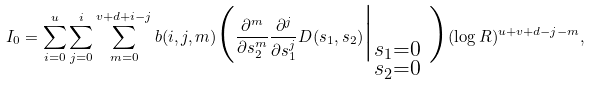Convert formula to latex. <formula><loc_0><loc_0><loc_500><loc_500>I _ { 0 } = \sum ^ { u } _ { i = 0 } \sum _ { j = 0 } ^ { i } \sum _ { m = 0 } ^ { v + d + i - j } b ( i , j , m ) \Big ( \frac { \partial ^ { m } } { \partial s ^ { m } _ { 2 } } \frac { \partial ^ { j } } { \partial s ^ { j } _ { 1 } } D ( s _ { 1 } , s _ { 2 } ) \Big | _ { \substack { s _ { 1 } = 0 \\ s _ { 2 } = 0 } } \ \Big ) ( \log R ) ^ { u + v + d - j - m } ,</formula> 